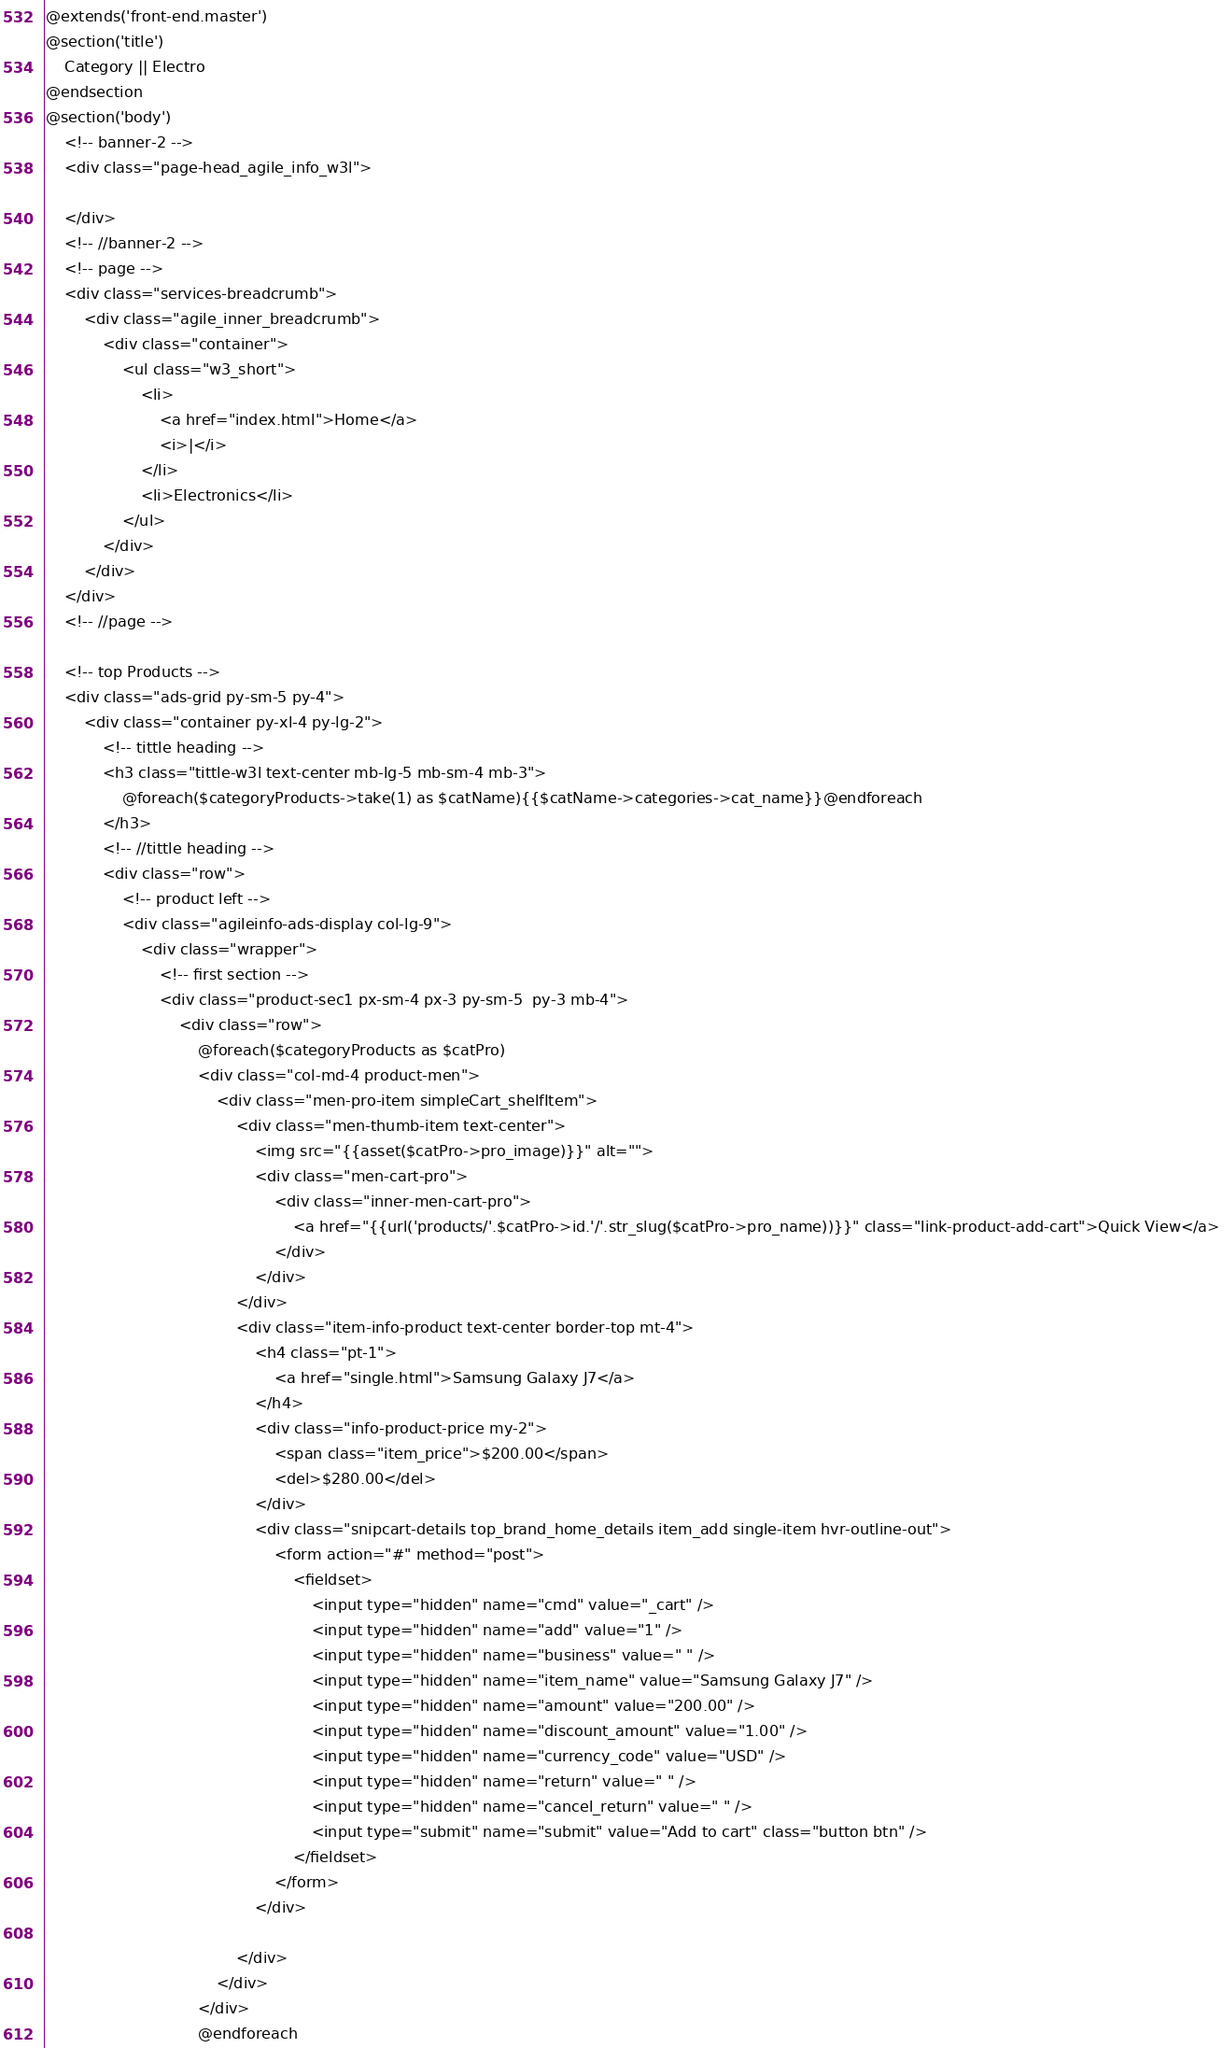Convert code to text. <code><loc_0><loc_0><loc_500><loc_500><_PHP_>@extends('front-end.master')
@section('title')
    Category || Electro
@endsection
@section('body')
    <!-- banner-2 -->
    <div class="page-head_agile_info_w3l">

    </div>
    <!-- //banner-2 -->
    <!-- page -->
    <div class="services-breadcrumb">
        <div class="agile_inner_breadcrumb">
            <div class="container">
                <ul class="w3_short">
                    <li>
                        <a href="index.html">Home</a>
                        <i>|</i>
                    </li>
                    <li>Electronics</li>
                </ul>
            </div>
        </div>
    </div>
    <!-- //page -->

    <!-- top Products -->
    <div class="ads-grid py-sm-5 py-4">
        <div class="container py-xl-4 py-lg-2">
            <!-- tittle heading -->
            <h3 class="tittle-w3l text-center mb-lg-5 mb-sm-4 mb-3">
                @foreach($categoryProducts->take(1) as $catName){{$catName->categories->cat_name}}@endforeach
            </h3>
            <!-- //tittle heading -->
            <div class="row">
                <!-- product left -->
                <div class="agileinfo-ads-display col-lg-9">
                    <div class="wrapper">
                        <!-- first section -->
                        <div class="product-sec1 px-sm-4 px-3 py-sm-5  py-3 mb-4">
                            <div class="row">
                                @foreach($categoryProducts as $catPro)
                                <div class="col-md-4 product-men">
                                    <div class="men-pro-item simpleCart_shelfItem">
                                        <div class="men-thumb-item text-center">
                                            <img src="{{asset($catPro->pro_image)}}" alt="">
                                            <div class="men-cart-pro">
                                                <div class="inner-men-cart-pro">
                                                    <a href="{{url('products/'.$catPro->id.'/'.str_slug($catPro->pro_name))}}" class="link-product-add-cart">Quick View</a>
                                                </div>
                                            </div>
                                        </div>
                                        <div class="item-info-product text-center border-top mt-4">
                                            <h4 class="pt-1">
                                                <a href="single.html">Samsung Galaxy J7</a>
                                            </h4>
                                            <div class="info-product-price my-2">
                                                <span class="item_price">$200.00</span>
                                                <del>$280.00</del>
                                            </div>
                                            <div class="snipcart-details top_brand_home_details item_add single-item hvr-outline-out">
                                                <form action="#" method="post">
                                                    <fieldset>
                                                        <input type="hidden" name="cmd" value="_cart" />
                                                        <input type="hidden" name="add" value="1" />
                                                        <input type="hidden" name="business" value=" " />
                                                        <input type="hidden" name="item_name" value="Samsung Galaxy J7" />
                                                        <input type="hidden" name="amount" value="200.00" />
                                                        <input type="hidden" name="discount_amount" value="1.00" />
                                                        <input type="hidden" name="currency_code" value="USD" />
                                                        <input type="hidden" name="return" value=" " />
                                                        <input type="hidden" name="cancel_return" value=" " />
                                                        <input type="submit" name="submit" value="Add to cart" class="button btn" />
                                                    </fieldset>
                                                </form>
                                            </div>

                                        </div>
                                    </div>
                                </div>
                                @endforeach
</code> 